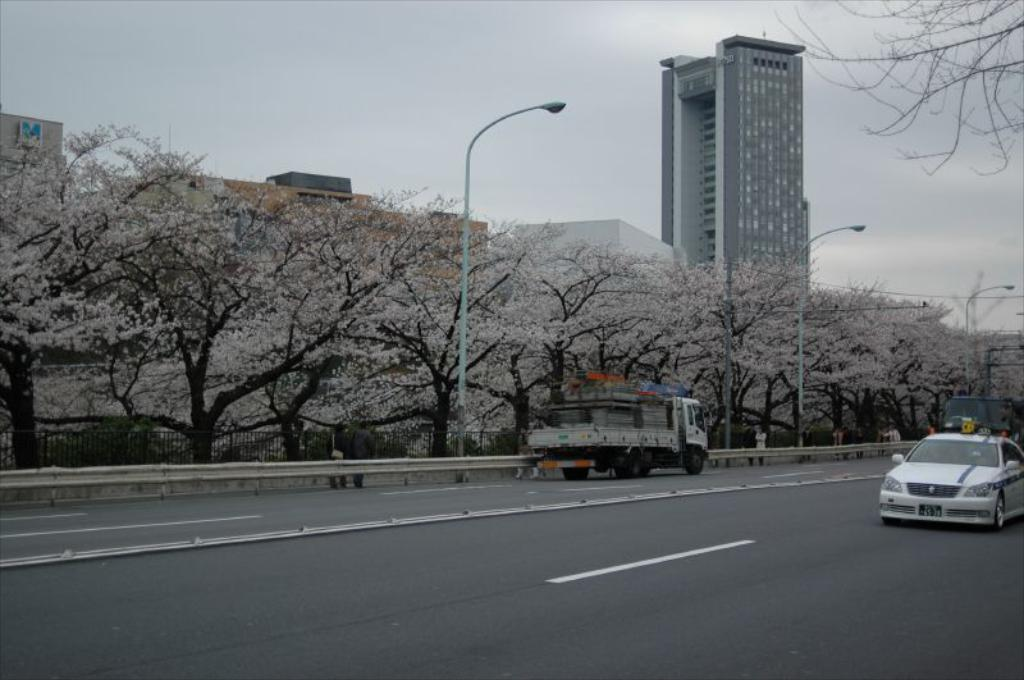What can be seen on the road in the image? There are vehicles on the road in the image. What type of lighting is present along the road? There are street lights in the image. What can be seen in the background of the image? There are trees and buildings in the background of the image. What is visible in the sky in the image? The sky is visible in the background of the image. What type of sticks are being used to plant the quince in the image? There are no sticks or quince present in the image; it features vehicles on the road, street lights, trees, buildings, and the sky. 